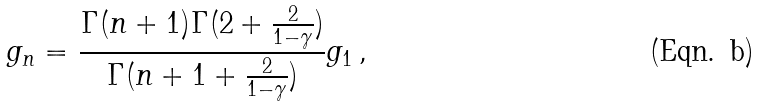Convert formula to latex. <formula><loc_0><loc_0><loc_500><loc_500>g _ { n } = \frac { \Gamma ( n + 1 ) \Gamma ( 2 + \frac { 2 } { 1 - \gamma } ) } { \Gamma ( n + 1 + \frac { 2 } { 1 - \gamma } ) } g _ { 1 } \, ,</formula> 